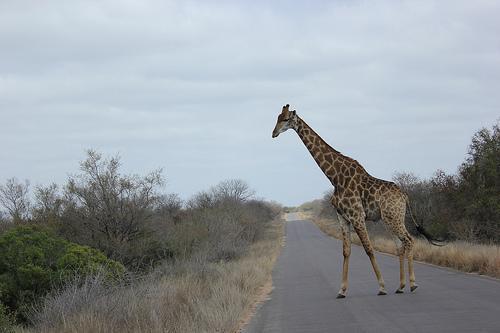How many animals are here?
Give a very brief answer. 1. 